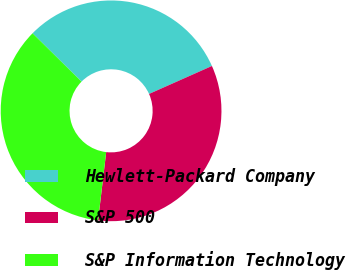<chart> <loc_0><loc_0><loc_500><loc_500><pie_chart><fcel>Hewlett-Packard Company<fcel>S&P 500<fcel>S&P Information Technology<nl><fcel>30.94%<fcel>33.54%<fcel>35.52%<nl></chart> 